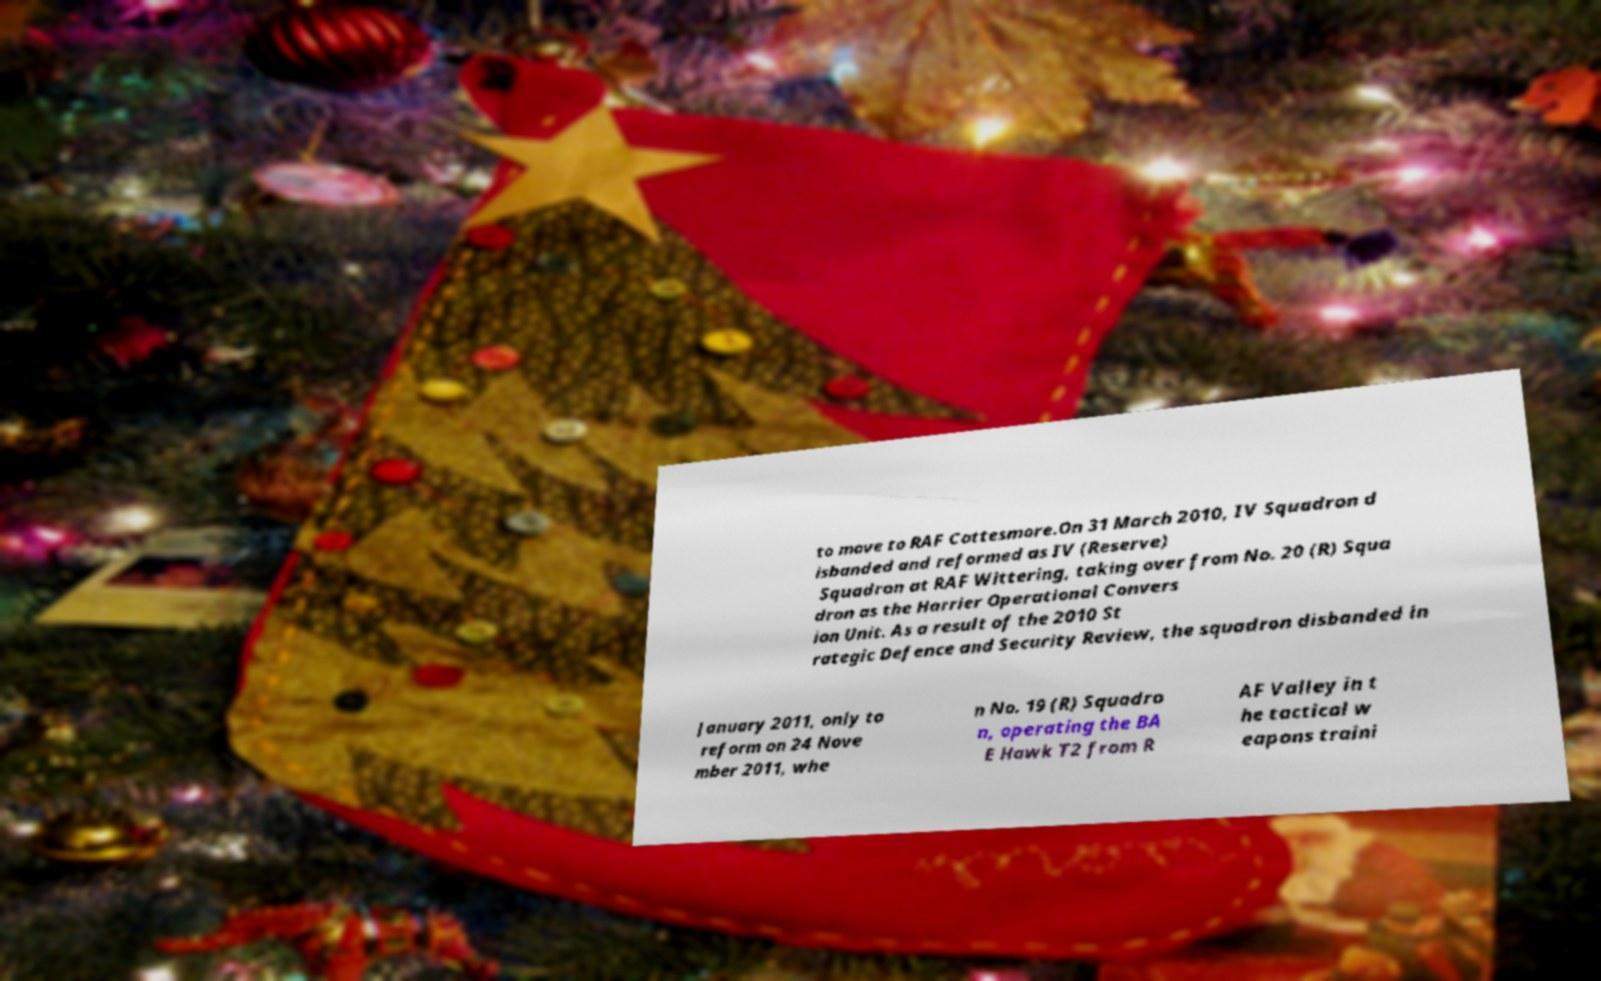Can you read and provide the text displayed in the image?This photo seems to have some interesting text. Can you extract and type it out for me? to move to RAF Cottesmore.On 31 March 2010, IV Squadron d isbanded and reformed as IV (Reserve) Squadron at RAF Wittering, taking over from No. 20 (R) Squa dron as the Harrier Operational Convers ion Unit. As a result of the 2010 St rategic Defence and Security Review, the squadron disbanded in January 2011, only to reform on 24 Nove mber 2011, whe n No. 19 (R) Squadro n, operating the BA E Hawk T2 from R AF Valley in t he tactical w eapons traini 